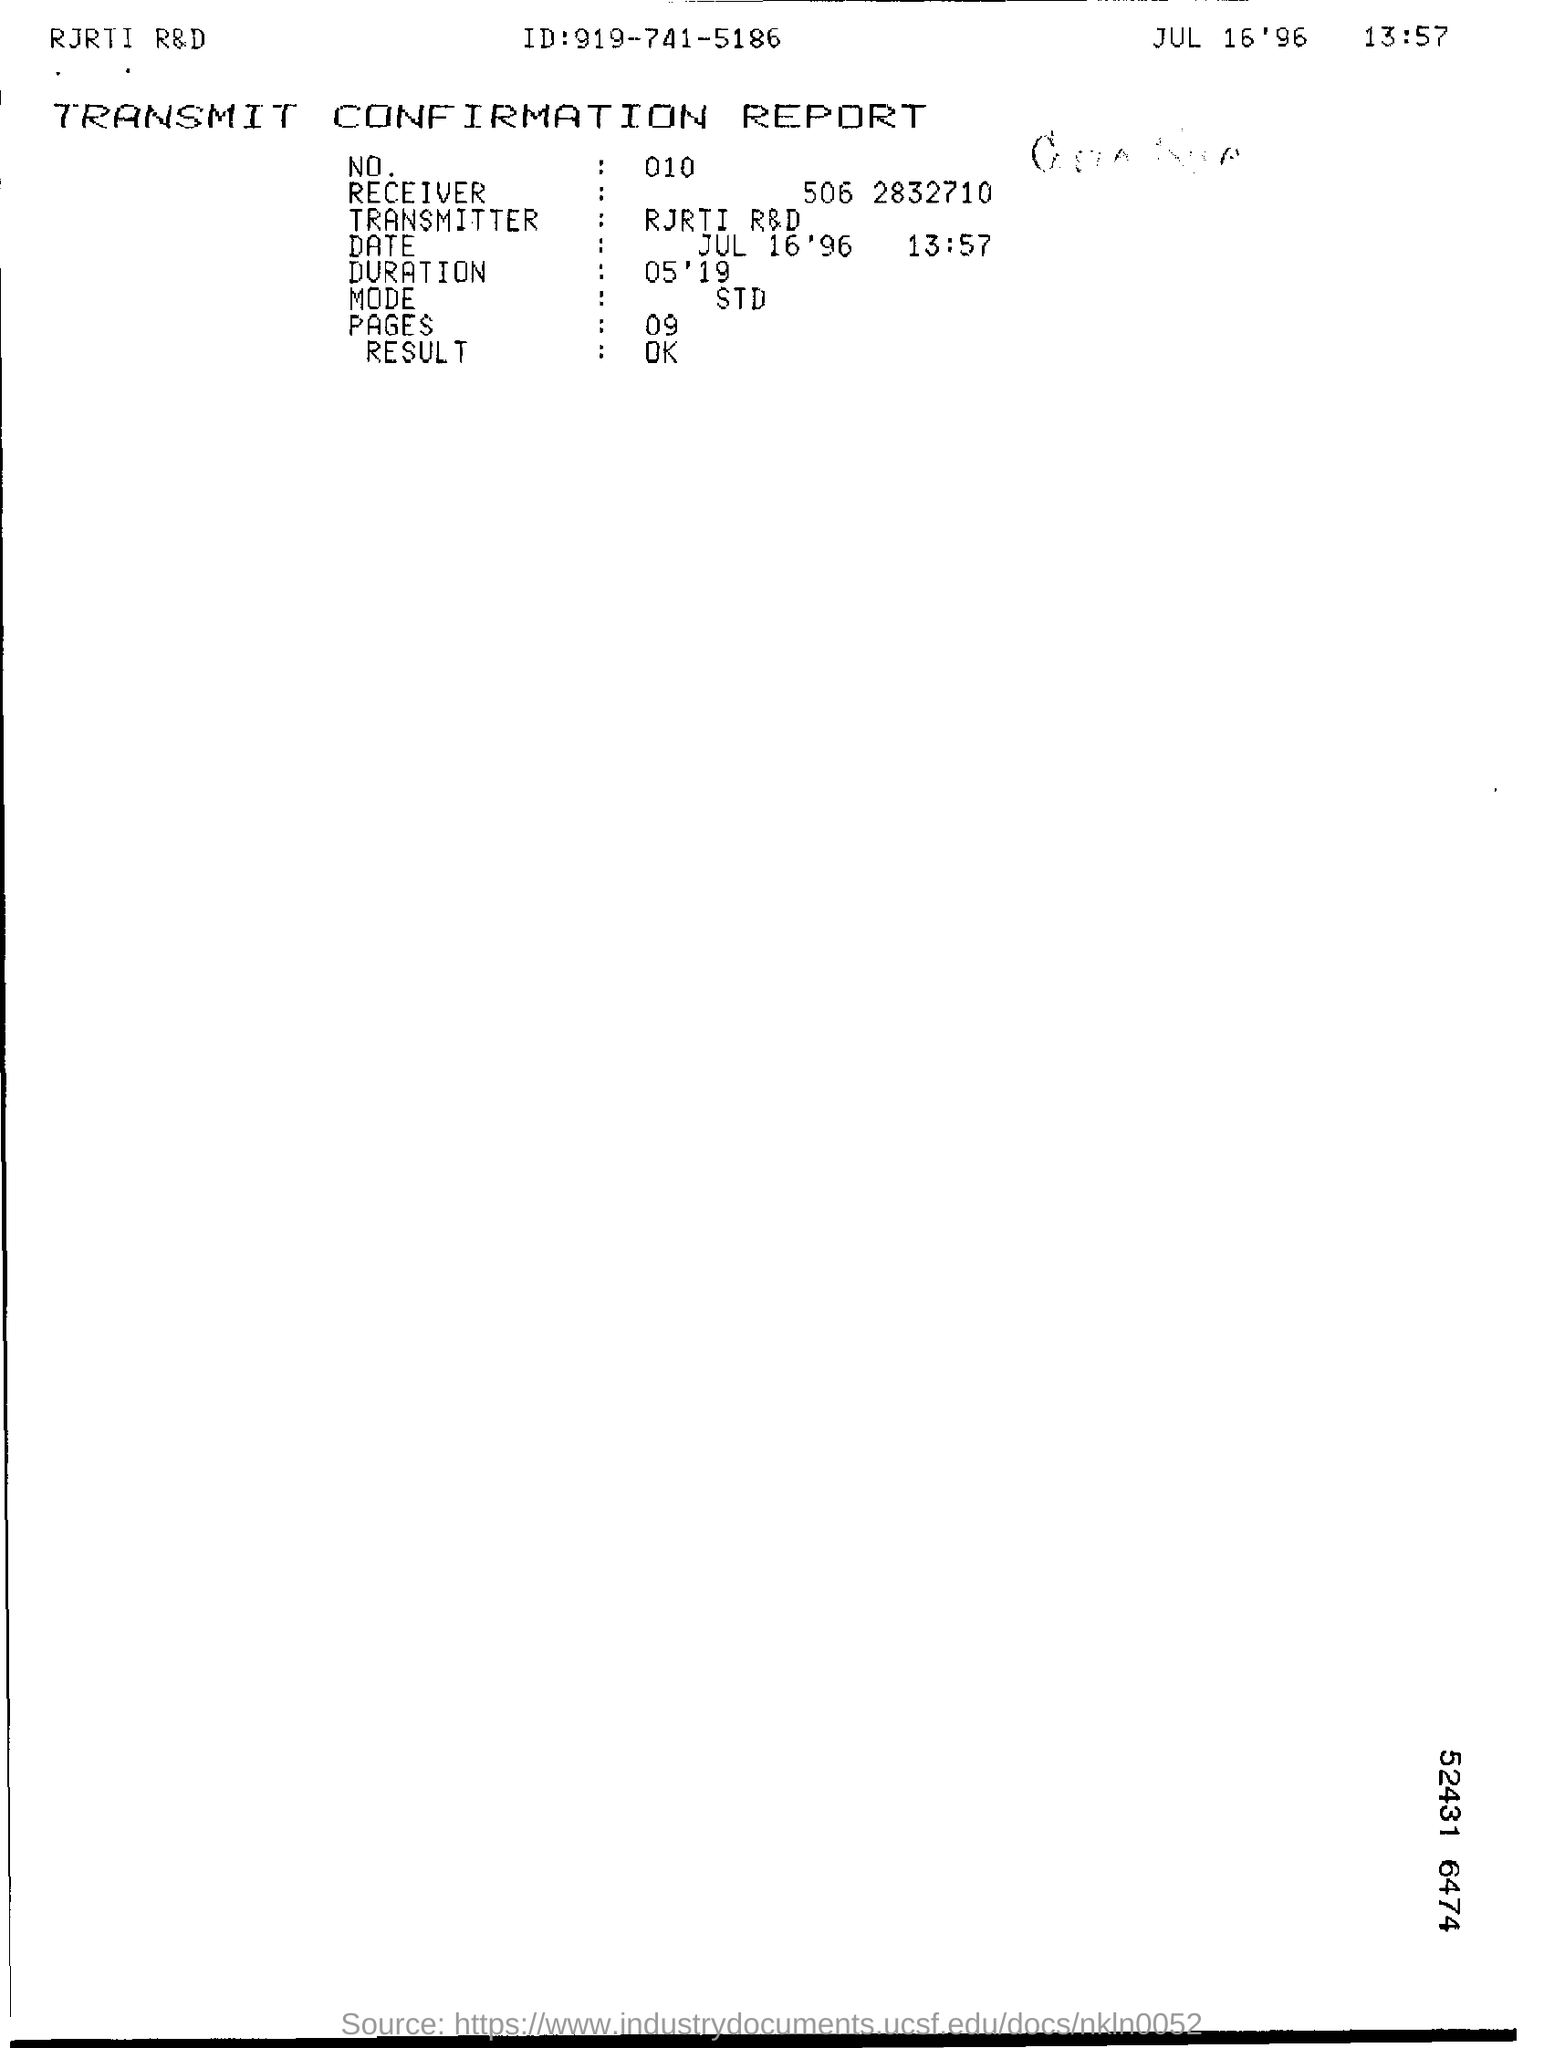What is the heading of the document?
Make the answer very short. TRANSMIT CONFIRMATION REPORT. 